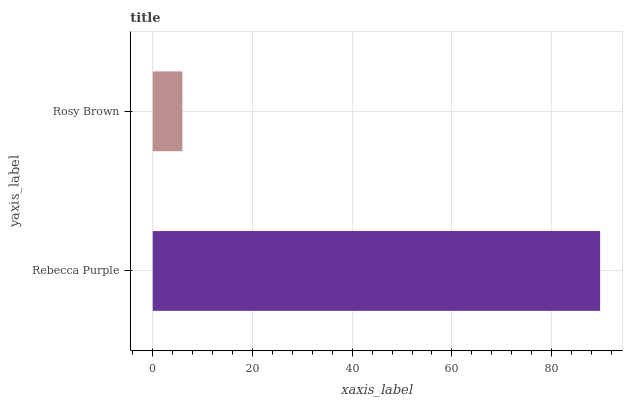Is Rosy Brown the minimum?
Answer yes or no. Yes. Is Rebecca Purple the maximum?
Answer yes or no. Yes. Is Rosy Brown the maximum?
Answer yes or no. No. Is Rebecca Purple greater than Rosy Brown?
Answer yes or no. Yes. Is Rosy Brown less than Rebecca Purple?
Answer yes or no. Yes. Is Rosy Brown greater than Rebecca Purple?
Answer yes or no. No. Is Rebecca Purple less than Rosy Brown?
Answer yes or no. No. Is Rebecca Purple the high median?
Answer yes or no. Yes. Is Rosy Brown the low median?
Answer yes or no. Yes. Is Rosy Brown the high median?
Answer yes or no. No. Is Rebecca Purple the low median?
Answer yes or no. No. 